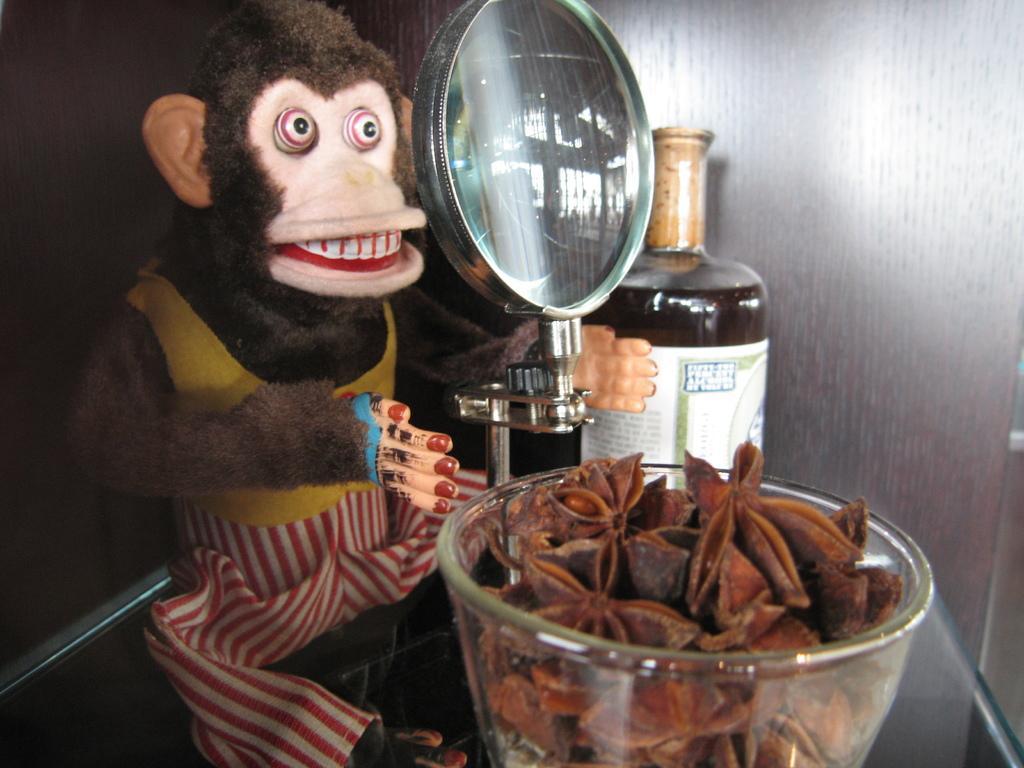Could you give a brief overview of what you see in this image? In the foreground of the picture there is a bowl, in the bowl there are star anise. In the center of the picture there are bottle, monkey toy and magnifier. In the background it is well. 